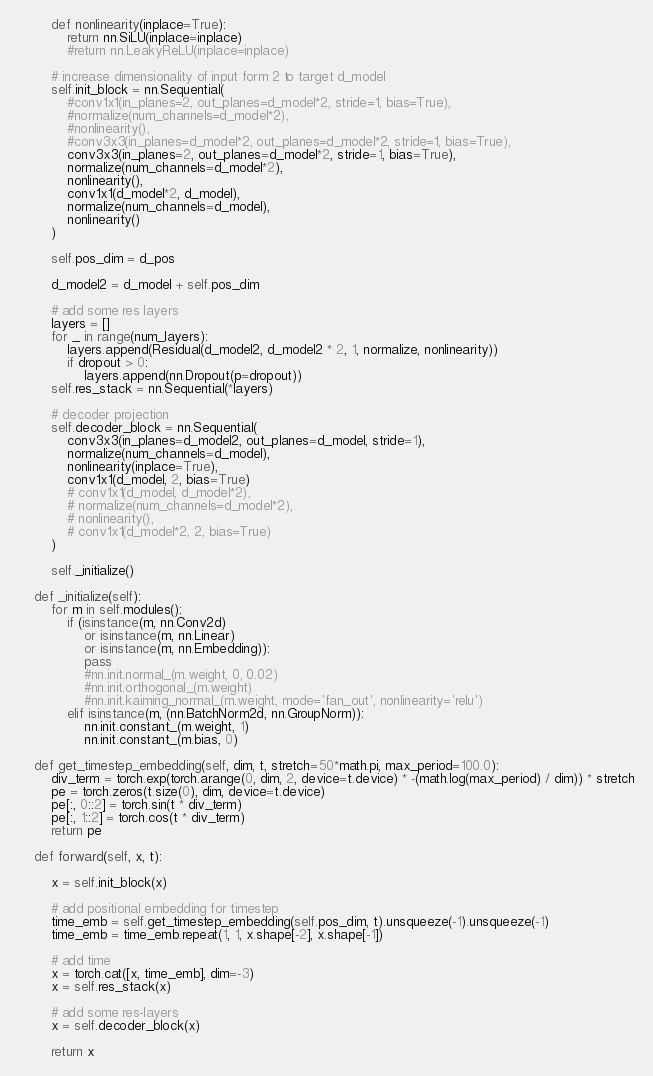Convert code to text. <code><loc_0><loc_0><loc_500><loc_500><_Python_>        def nonlinearity(inplace=True):
            return nn.SiLU(inplace=inplace)
            #return nn.LeakyReLU(inplace=inplace)

        # increase dimensionality of input form 2 to target d_model
        self.init_block = nn.Sequential(
            #conv1x1(in_planes=2, out_planes=d_model*2, stride=1, bias=True),
            #normalize(num_channels=d_model*2),
            #nonlinearity(),
            #conv3x3(in_planes=d_model*2, out_planes=d_model*2, stride=1, bias=True),
            conv3x3(in_planes=2, out_planes=d_model*2, stride=1, bias=True),
            normalize(num_channels=d_model*2),
            nonlinearity(),
            conv1x1(d_model*2, d_model),
            normalize(num_channels=d_model),
            nonlinearity()
        )

        self.pos_dim = d_pos

        d_model2 = d_model + self.pos_dim

        # add some res layers
        layers = []
        for _ in range(num_layers):
            layers.append(Residual(d_model2, d_model2 * 2, 1, normalize, nonlinearity))
            if dropout > 0:
                layers.append(nn.Dropout(p=dropout))
        self.res_stack = nn.Sequential(*layers)

        # decoder projection
        self.decoder_block = nn.Sequential(
            conv3x3(in_planes=d_model2, out_planes=d_model, stride=1),
            normalize(num_channels=d_model),
            nonlinearity(inplace=True),
            conv1x1(d_model, 2, bias=True)
            # conv1x1(d_model, d_model*2),
            # normalize(num_channels=d_model*2),
            # nonlinearity(),
            # conv1x1(d_model*2, 2, bias=True)   
        )

        self._initialize()

    def _initialize(self):
        for m in self.modules():
            if (isinstance(m, nn.Conv2d)
                or isinstance(m, nn.Linear) 
                or isinstance(m, nn.Embedding)):
                pass
                #nn.init.normal_(m.weight, 0, 0.02)
                #nn.init.orthogonal_(m.weight)
                #nn.init.kaiming_normal_(m.weight, mode='fan_out', nonlinearity='relu')
            elif isinstance(m, (nn.BatchNorm2d, nn.GroupNorm)):
                nn.init.constant_(m.weight, 1)
                nn.init.constant_(m.bias, 0)

    def get_timestep_embedding(self, dim, t, stretch=50*math.pi, max_period=100.0):
        div_term = torch.exp(torch.arange(0, dim, 2, device=t.device) * -(math.log(max_period) / dim)) * stretch
        pe = torch.zeros(t.size(0), dim, device=t.device)
        pe[:, 0::2] = torch.sin(t * div_term)
        pe[:, 1::2] = torch.cos(t * div_term)
        return pe

    def forward(self, x, t):
        
        x = self.init_block(x)
        
        # add positional embedding for timestep
        time_emb = self.get_timestep_embedding(self.pos_dim, t).unsqueeze(-1).unsqueeze(-1)
        time_emb = time_emb.repeat(1, 1, x.shape[-2], x.shape[-1])

        # add time
        x = torch.cat([x, time_emb], dim=-3)
        x = self.res_stack(x)
        
        # add some res-layers 
        x = self.decoder_block(x)
        
        return x
</code> 